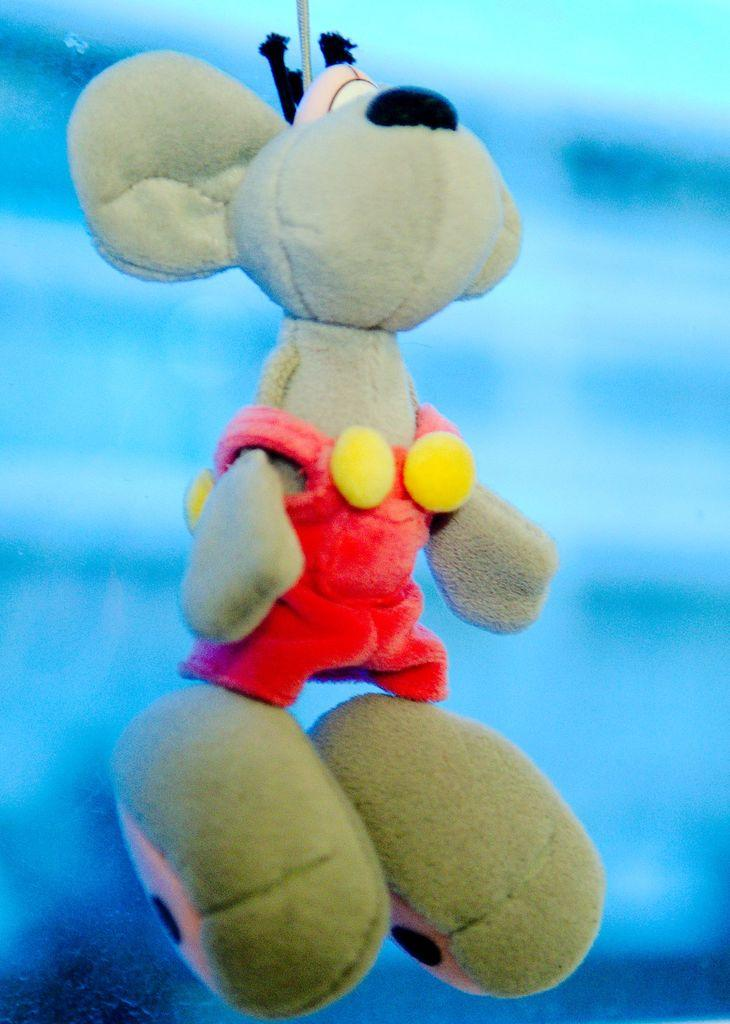What object is the main focus of the picture? There is a toy in the picture. Can you describe the background of the image? The background of the image is blurred. How many rabbits can be seen in the picture? There are no rabbits present in the picture; it features a toy. What time of day is depicted in the image? The time of day cannot be determined from the image, as there is no reference to time or lighting that would indicate morning or any other time. 